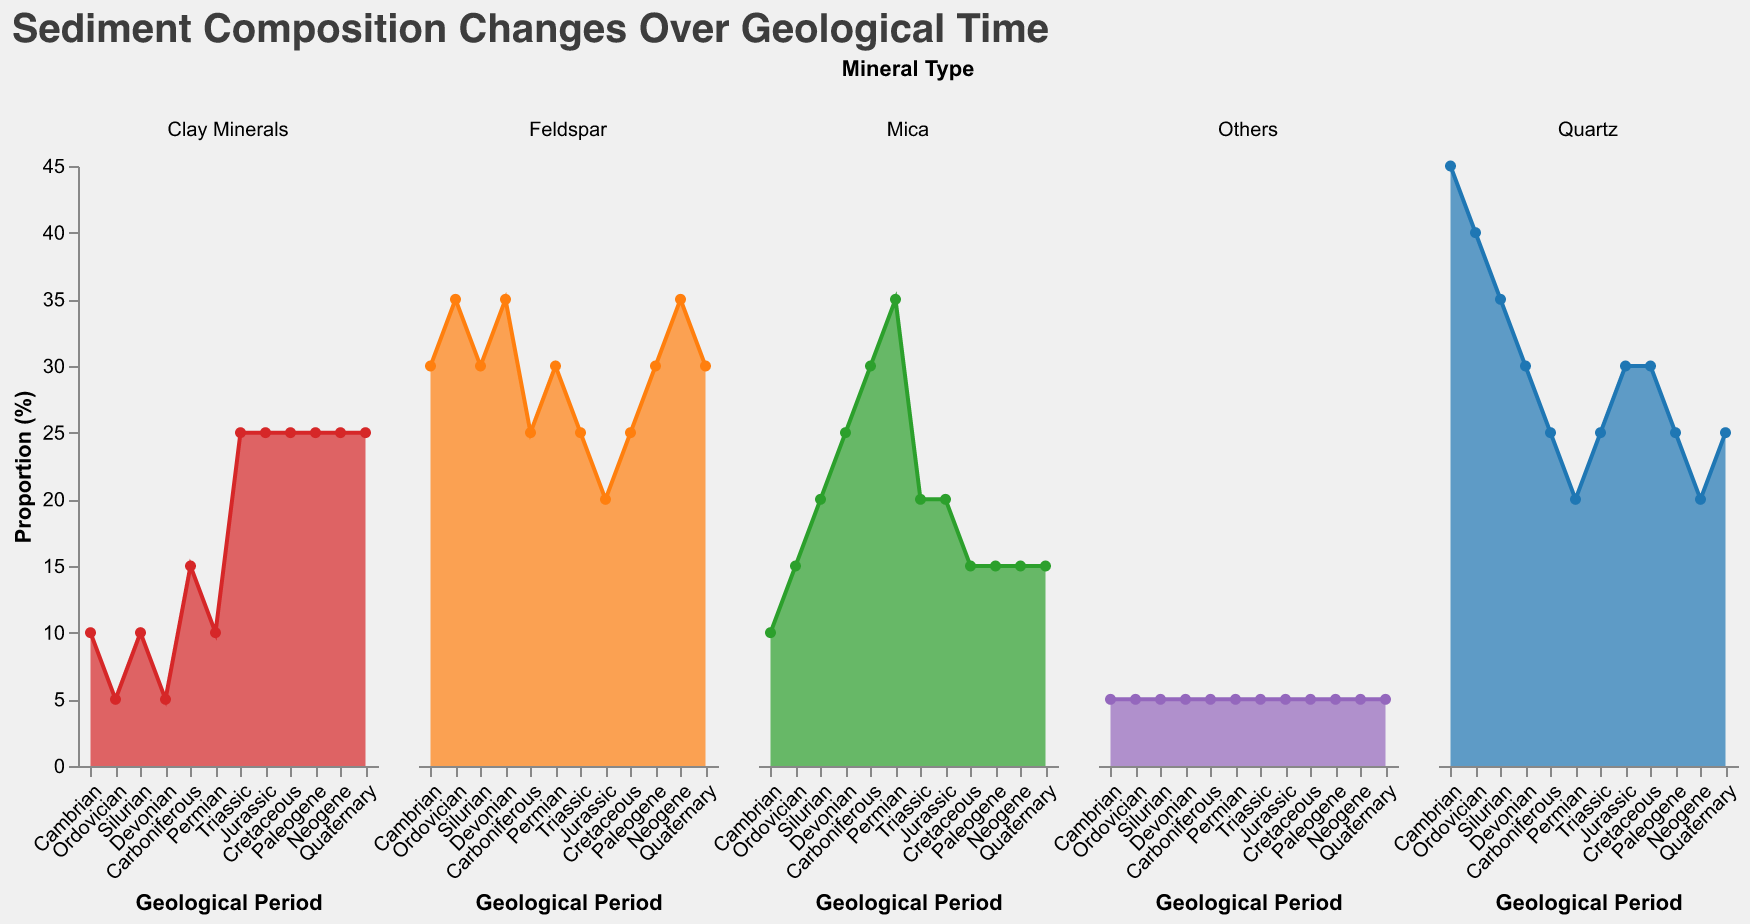What is the title of the figure? The title is displayed at the top of the figure. It reads "Sediment Composition Changes Over Geological Time".
Answer: Sediment Composition Changes Over Geological Time Which mineral has the highest proportion in the Cambrian period? Look for the Cambrian period and identify the mineral with the highest proporion in the bar chart.
Answer: Quartz What is the average proportion of Feldspar from the Cambrian to Quaternary periods? Sum the proportions of Feldspar for each period and divide by the number of periods (12). (30+35+30+35+25+30+25+20+25+30+35+30)/12 = 30
Answer: 30% How does the proportion of Quartz change from the Cambrian to the Permian? Observe the Quartz proportions for each period from Cambrian to Permian: 45% (Cambrian), 40% (Ordovician), 35% (Silurian), 30% (Devonian), 25% (Carboniferous), 20% (Permian). There is a general decreasing trend.
Answer: Decreasing In which geological period does Mica have its highest proportion? Check for the highest value of Mica across all periods to find it: 35% in the Permian period.
Answer: Permian Which mineral shows the most significant increase in proportion during the Triassic period? Identify the mineral with the largest positive change in proportion in the Triassic period compared to the previous (Permian) period. Clay Minerals show a significant increase from 10% to 25%.
Answer: Clay Minerals Between which two consecutive periods does the proportion of Quartz show the largest decrease? Compare the Quartz proportions in each pair of consecutive periods and identify the largest decrease: from Cambrian (45%) to Ordovician (40%), decrease by 5%.
Answer: Cambrian to Ordovician Which geological period has the most even distribution (i.e., smallest range) of mineral proportions? Calculate the range (difference between the highest and lowest proportions) for each period and identify the smallest range: Neogene Quartz (20%), Feldspar (35%), Mica (15%), Clay Minerals (25%), Others (5%). Range is 30.
Answer: Neogene Is there a period where the proportion of Clay Minerals is consistently higher than 20%? Review each period for proportions of Clay Minerals and identify if it stays consistently over 20%. Only from Triassic (25%) to Quaternary (25%).
Answer: Triassic, Jurassic, Cretaceous, Paleogene, Neogene, Quaternary In the Jurassic period, which minerals combine to make up exactly half of the total proportion? Look at the Jurassic period data and identify combinations of minerals: Quartz (30%) + Others (5%) = 35%, Quartz (30%) + Mica (20%) = 50%.
Answer: Quartz and Mica 